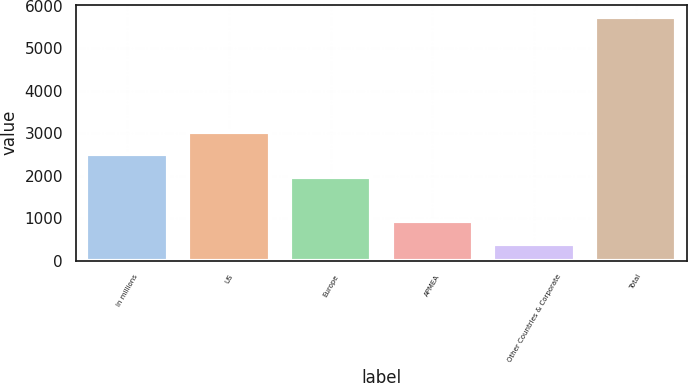Convert chart to OTSL. <chart><loc_0><loc_0><loc_500><loc_500><bar_chart><fcel>In millions<fcel>US<fcel>Europe<fcel>APMEA<fcel>Other Countries & Corporate<fcel>Total<nl><fcel>2499.3<fcel>3033.6<fcel>1965<fcel>922.3<fcel>388<fcel>5731<nl></chart> 